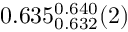<formula> <loc_0><loc_0><loc_500><loc_500>0 . 6 3 5 _ { 0 . 6 3 2 } ^ { 0 . 6 4 0 } ( 2 )</formula> 